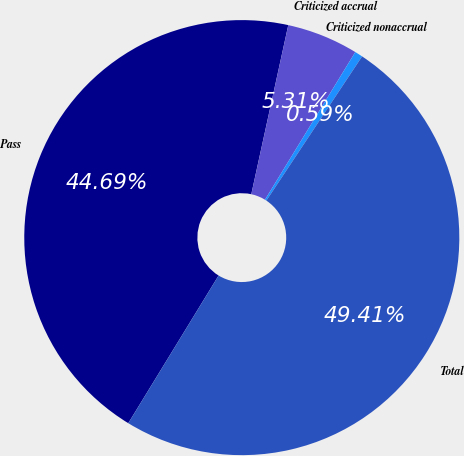<chart> <loc_0><loc_0><loc_500><loc_500><pie_chart><fcel>Pass<fcel>Criticized accrual<fcel>Criticized nonaccrual<fcel>Total<nl><fcel>44.69%<fcel>5.31%<fcel>0.59%<fcel>49.41%<nl></chart> 